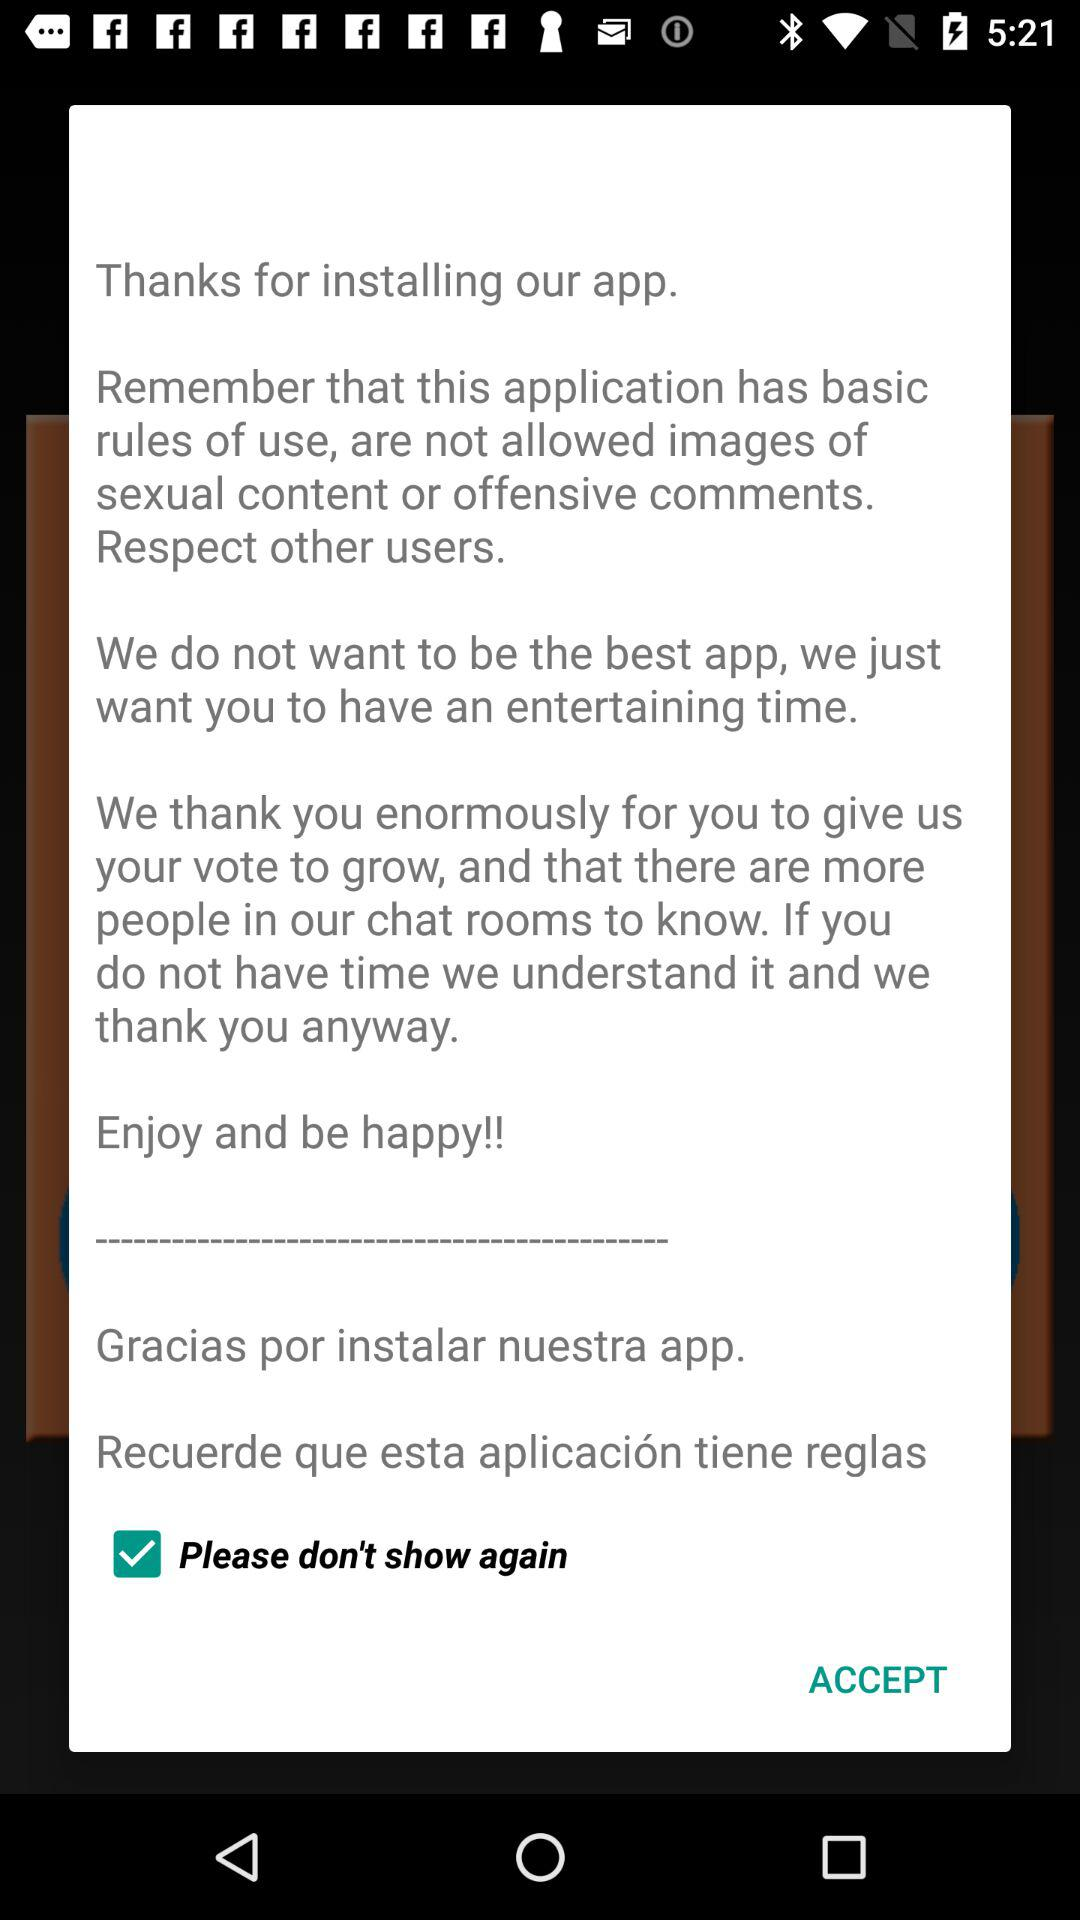What's the status of "Please don't show again"? The status of "Please don't show again" is "on". 